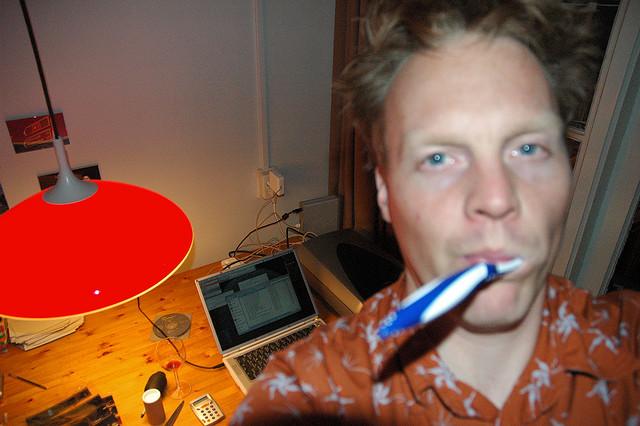What color is the lamp to the left of the man?
Short answer required. Red. What is in the man's mouth?
Give a very brief answer. Toothbrush. What electronic is behind the man?
Give a very brief answer. Laptop. 